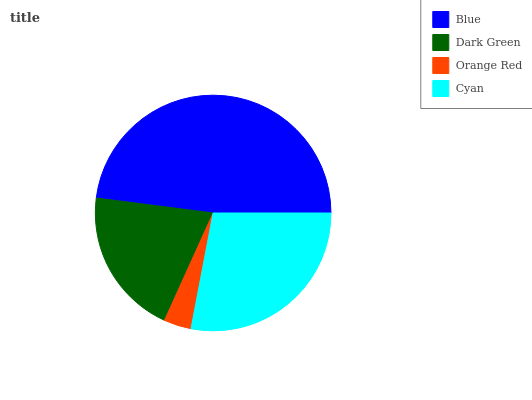Is Orange Red the minimum?
Answer yes or no. Yes. Is Blue the maximum?
Answer yes or no. Yes. Is Dark Green the minimum?
Answer yes or no. No. Is Dark Green the maximum?
Answer yes or no. No. Is Blue greater than Dark Green?
Answer yes or no. Yes. Is Dark Green less than Blue?
Answer yes or no. Yes. Is Dark Green greater than Blue?
Answer yes or no. No. Is Blue less than Dark Green?
Answer yes or no. No. Is Cyan the high median?
Answer yes or no. Yes. Is Dark Green the low median?
Answer yes or no. Yes. Is Orange Red the high median?
Answer yes or no. No. Is Blue the low median?
Answer yes or no. No. 